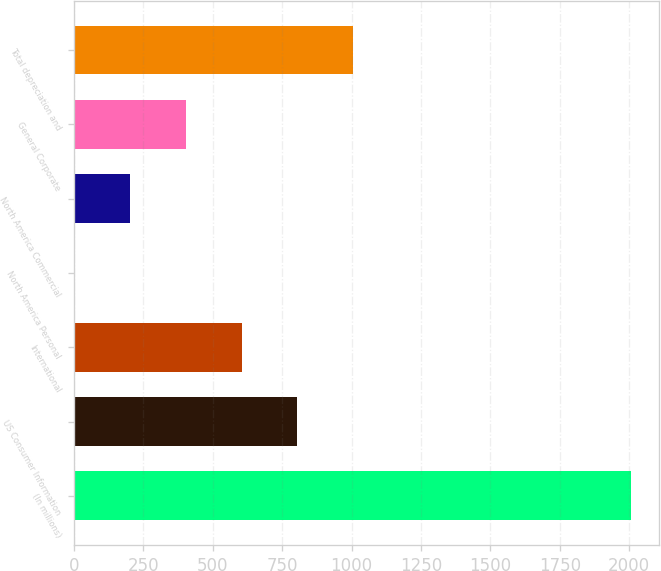Convert chart. <chart><loc_0><loc_0><loc_500><loc_500><bar_chart><fcel>(In millions)<fcel>US Consumer Information<fcel>International<fcel>North America Personal<fcel>North America Commercial<fcel>General Corporate<fcel>Total depreciation and<nl><fcel>2007<fcel>804.54<fcel>604.13<fcel>2.9<fcel>203.31<fcel>403.72<fcel>1004.95<nl></chart> 